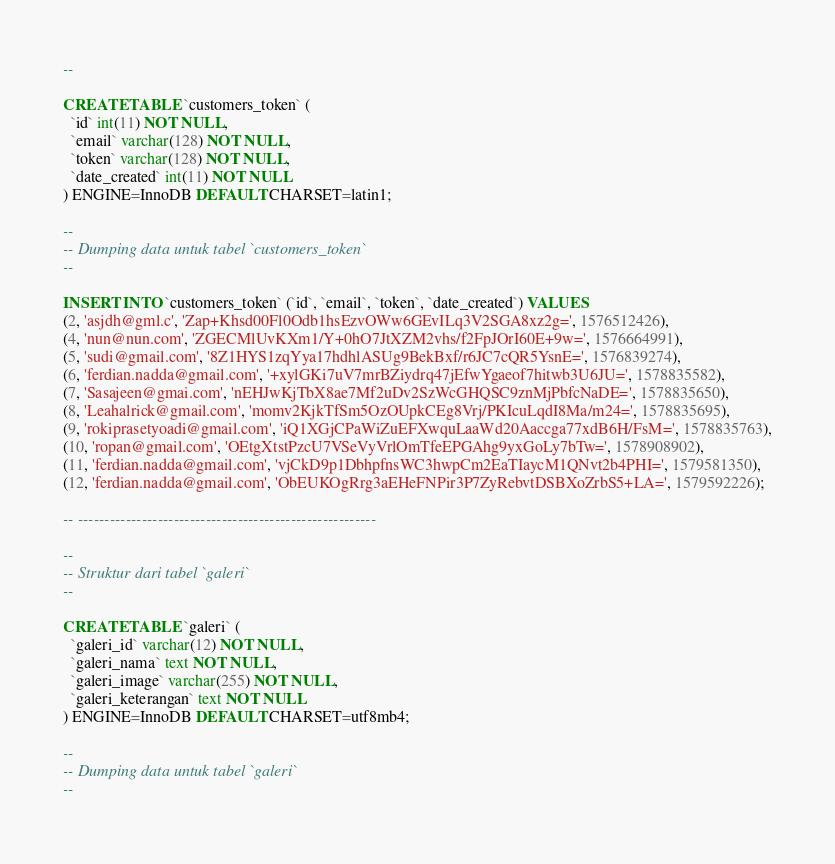<code> <loc_0><loc_0><loc_500><loc_500><_SQL_>--

CREATE TABLE `customers_token` (
  `id` int(11) NOT NULL,
  `email` varchar(128) NOT NULL,
  `token` varchar(128) NOT NULL,
  `date_created` int(11) NOT NULL
) ENGINE=InnoDB DEFAULT CHARSET=latin1;

--
-- Dumping data untuk tabel `customers_token`
--

INSERT INTO `customers_token` (`id`, `email`, `token`, `date_created`) VALUES
(2, 'asjdh@gml.c', 'Zap+Khsd00Fl0Odb1hsEzvOWw6GEvILq3V2SGA8xz2g=', 1576512426),
(4, 'nun@nun.com', 'ZGECMlUvKXm1/Y+0hO7JtXZM2vhs/f2FpJOrI60E+9w=', 1576664991),
(5, 'sudi@gmail.com', '8Z1HYS1zqYya17hdhlASUg9BekBxf/r6JC7cQR5YsnE=', 1576839274),
(6, 'ferdian.nadda@gmail.com', '+xylGKi7uV7mrBZiydrq47jEfwYgaeof7hitwb3U6JU=', 1578835582),
(7, 'Sasajeen@gmai.com', 'nEHJwKjTbX8ae7Mf2uDv2SzWcGHQSC9znMjPbfcNaDE=', 1578835650),
(8, 'Leahalrick@gmail.com', 'momv2KjkTfSm5OzOUpkCEg8Vrj/PKIcuLqdI8Ma/m24=', 1578835695),
(9, 'rokiprasetyoadi@gmail.com', 'iQ1XGjCPaWiZuEFXwquLaaWd20Aaccga77xdB6H/FsM=', 1578835763),
(10, 'ropan@gmail.com', 'OEtgXtstPzcU7VSeVyVrlOmTfeEPGAhg9yxGoLy7bTw=', 1578908902),
(11, 'ferdian.nadda@gmail.com', 'vjCkD9p1DbhpfnsWC3hwpCm2EaTIaycM1QNvt2b4PHI=', 1579581350),
(12, 'ferdian.nadda@gmail.com', 'ObEUKOgRrg3aEHeFNPir3P7ZyRebvtDSBXoZrbS5+LA=', 1579592226);

-- --------------------------------------------------------

--
-- Struktur dari tabel `galeri`
--

CREATE TABLE `galeri` (
  `galeri_id` varchar(12) NOT NULL,
  `galeri_nama` text NOT NULL,
  `galeri_image` varchar(255) NOT NULL,
  `galeri_keterangan` text NOT NULL
) ENGINE=InnoDB DEFAULT CHARSET=utf8mb4;

--
-- Dumping data untuk tabel `galeri`
--
</code> 